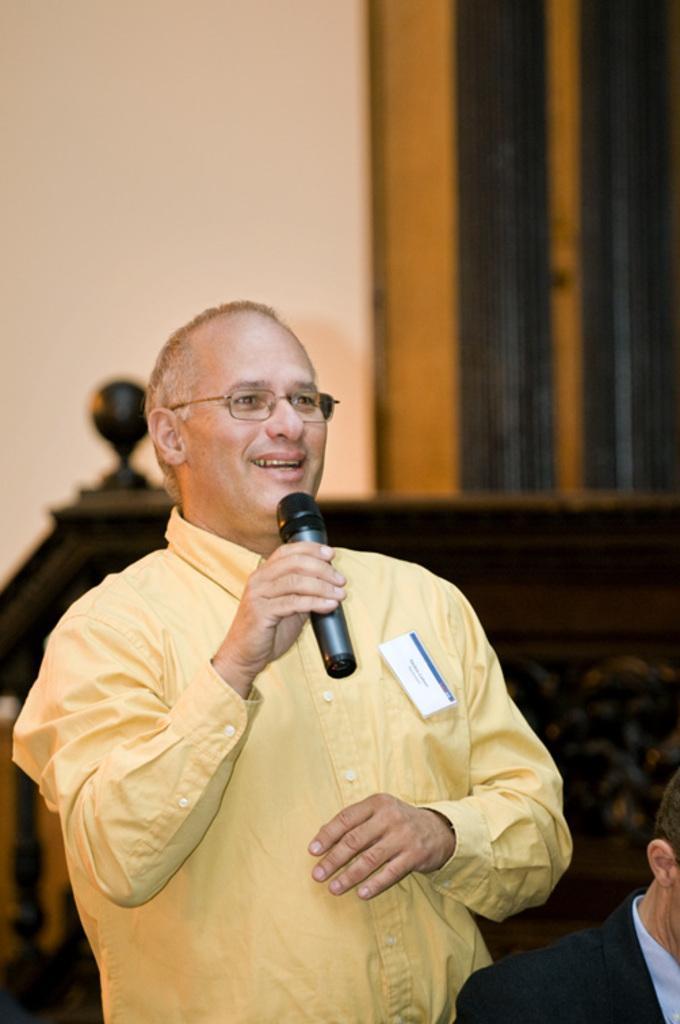Describe this image in one or two sentences. In this picture we can see a man standing and holding a microphone in his hand ,and he is smiling, and in front a man is sitting. 